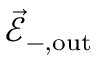Convert formula to latex. <formula><loc_0><loc_0><loc_500><loc_500>\vec { \mathcal { E } } _ { - , o u t }</formula> 